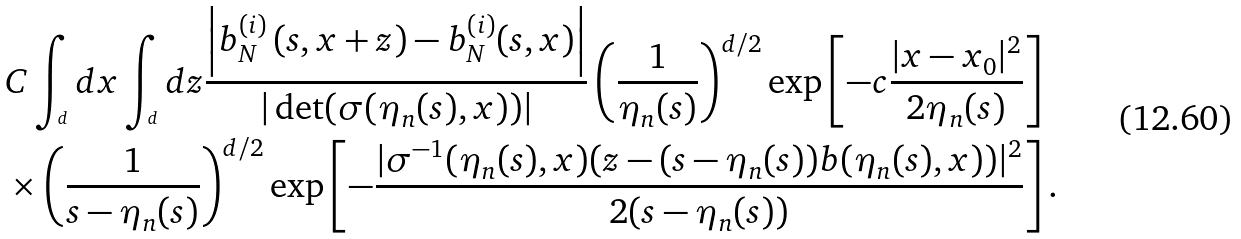Convert formula to latex. <formula><loc_0><loc_0><loc_500><loc_500>& C \int _ { \real ^ { d } } d x \int _ { \real ^ { d } } d z \frac { \left | b _ { N } ^ { ( i ) } \left ( s , x + z \right ) - b _ { N } ^ { ( i ) } ( s , x ) \right | } { | \det ( \sigma ( \eta _ { n } ( s ) , x ) ) | } \left ( \frac { 1 } { \eta _ { n } ( s ) } \right ) ^ { d / 2 } \exp \left [ - c \frac { | x - x _ { 0 } | ^ { 2 } } { 2 \eta _ { n } ( s ) } \right ] \\ & \times \left ( \frac { 1 } { s - \eta _ { n } ( s ) } \right ) ^ { d / 2 } \exp \left [ - \frac { | \sigma ^ { - 1 } ( \eta _ { n } ( s ) , x ) ( z - ( s - \eta _ { n } ( s ) ) b ( \eta _ { n } ( s ) , x ) ) | ^ { 2 } } { 2 ( s - \eta _ { n } ( s ) ) } \right ] .</formula> 